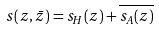<formula> <loc_0><loc_0><loc_500><loc_500>s ( z , \bar { z } ) = s _ { H } ( z ) + \overline { s _ { A } ( z ) }</formula> 